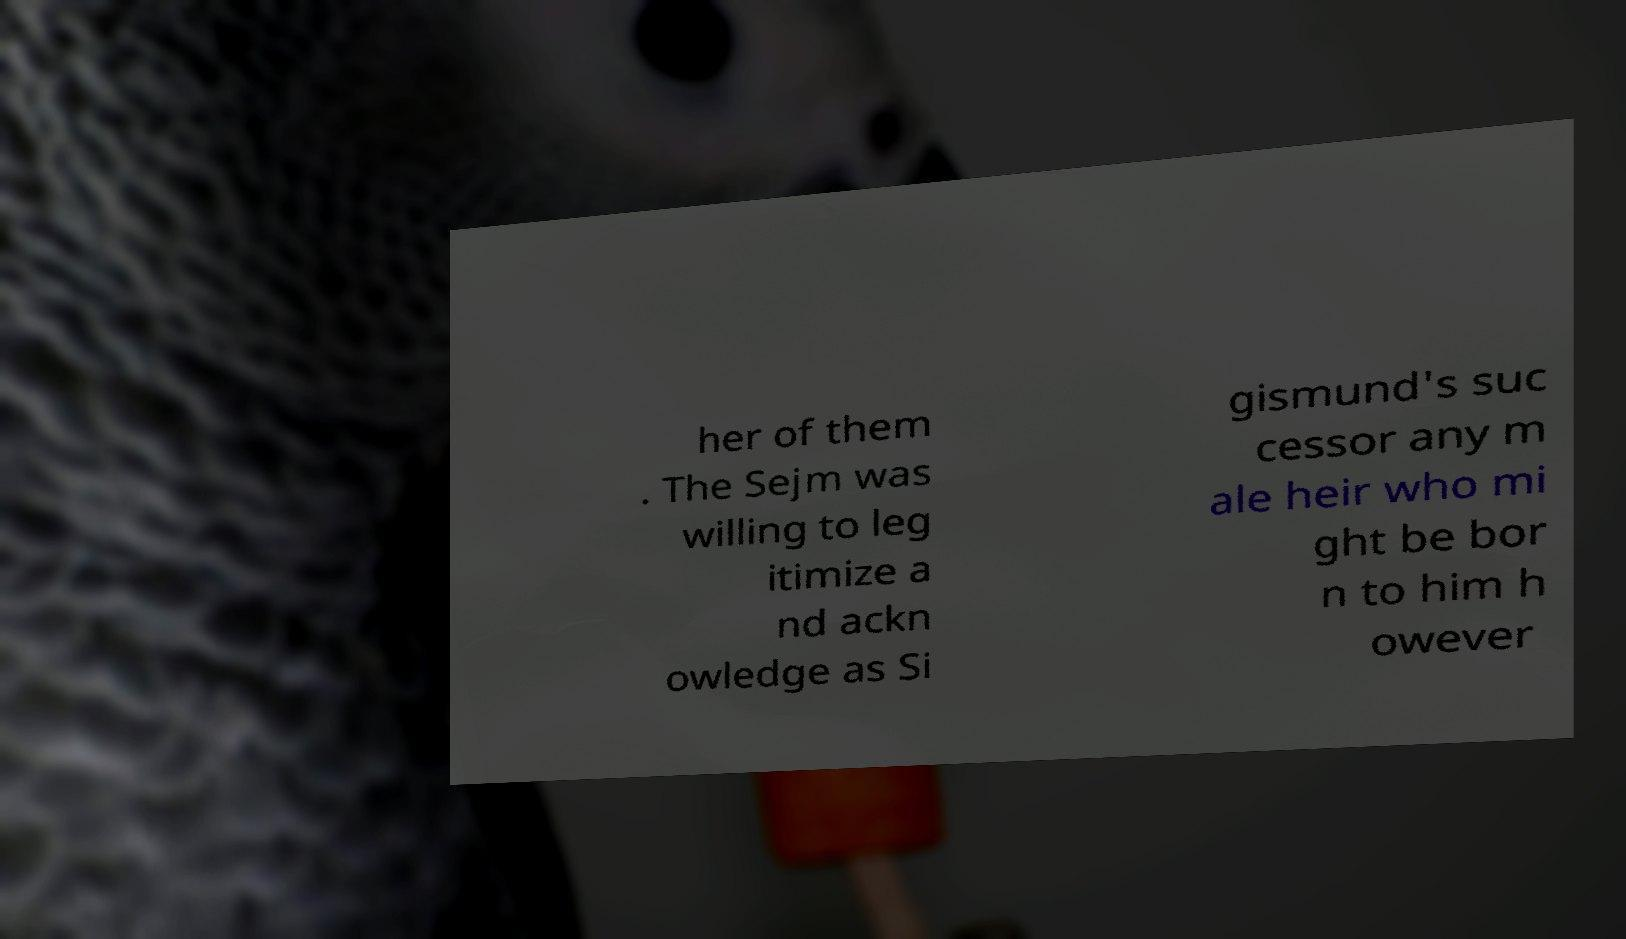There's text embedded in this image that I need extracted. Can you transcribe it verbatim? her of them . The Sejm was willing to leg itimize a nd ackn owledge as Si gismund's suc cessor any m ale heir who mi ght be bor n to him h owever 